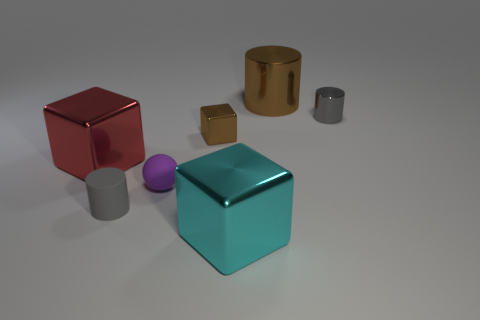There is a tiny cube that is the same color as the big cylinder; what material is it?
Your answer should be very brief. Metal. What number of rubber things are either yellow objects or big brown objects?
Provide a succinct answer. 0. Are there any tiny brown blocks behind the tiny matte thing that is right of the tiny gray thing that is in front of the brown cube?
Keep it short and to the point. Yes. What is the color of the rubber cylinder?
Make the answer very short. Gray. There is a tiny gray thing that is right of the cyan object; does it have the same shape as the big red object?
Keep it short and to the point. No. How many things are small blue metal things or cubes behind the gray matte object?
Keep it short and to the point. 2. Is the tiny cylinder behind the red metal thing made of the same material as the large red thing?
Provide a short and direct response. Yes. What is the gray thing that is in front of the gray thing that is behind the tiny brown thing made of?
Provide a short and direct response. Rubber. Are there more small purple spheres to the right of the tiny gray rubber object than big cyan metal blocks behind the brown metallic cylinder?
Offer a terse response. Yes. What is the size of the cyan object?
Your answer should be very brief. Large. 